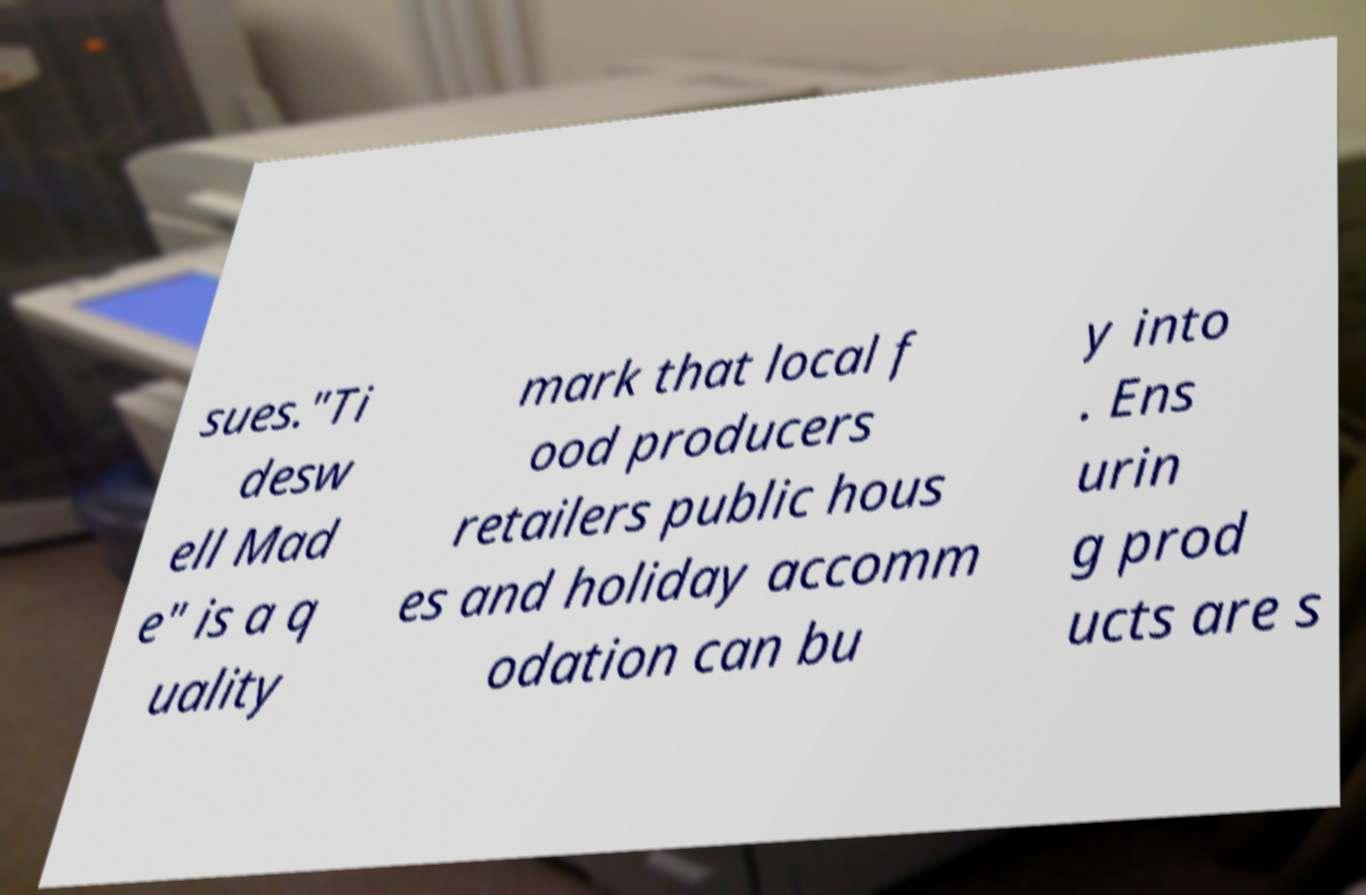Please identify and transcribe the text found in this image. sues."Ti desw ell Mad e" is a q uality mark that local f ood producers retailers public hous es and holiday accomm odation can bu y into . Ens urin g prod ucts are s 